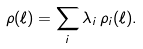Convert formula to latex. <formula><loc_0><loc_0><loc_500><loc_500>\rho ( \ell ) = \sum _ { i } \lambda _ { i } \, \rho _ { i } ( \ell ) .</formula> 